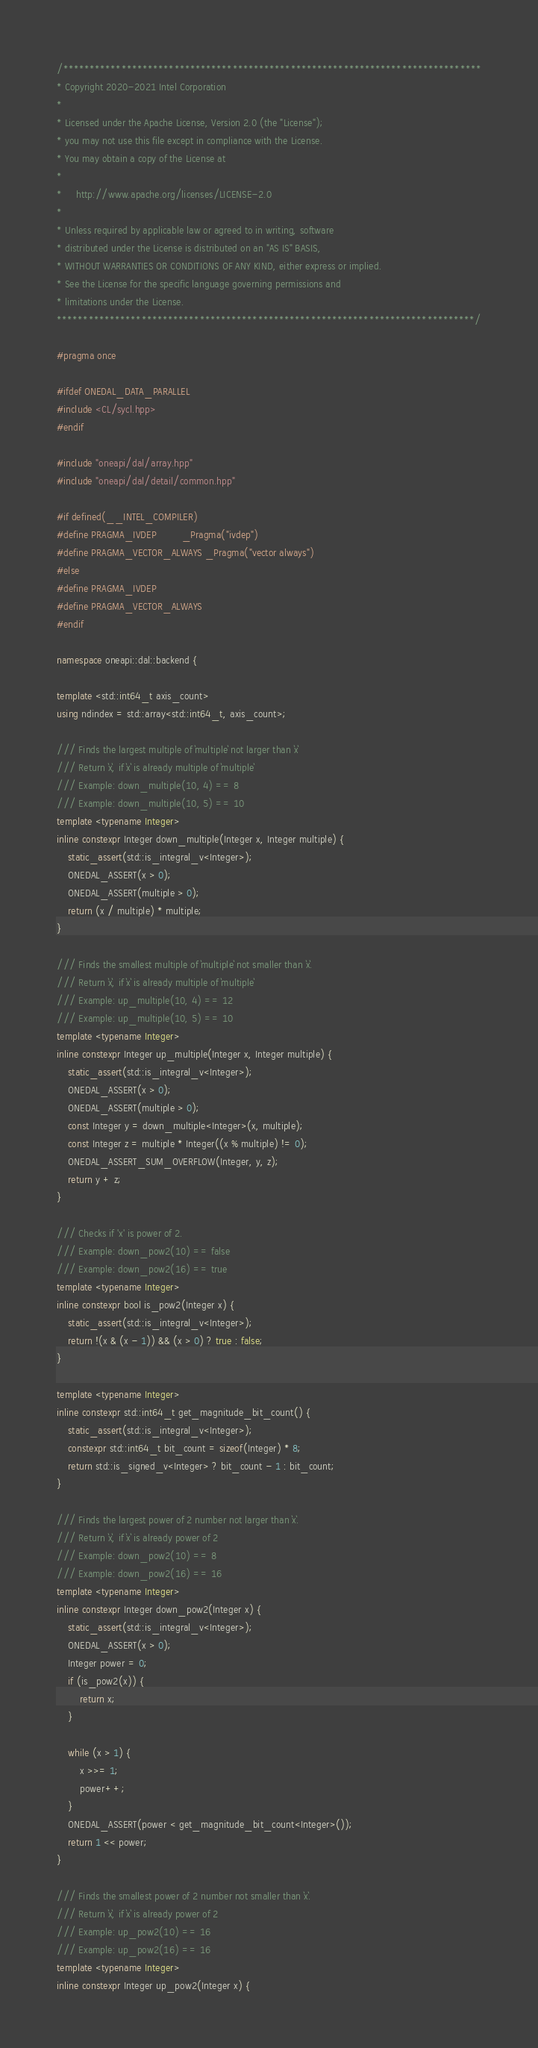<code> <loc_0><loc_0><loc_500><loc_500><_C++_>/*******************************************************************************
* Copyright 2020-2021 Intel Corporation
*
* Licensed under the Apache License, Version 2.0 (the "License");
* you may not use this file except in compliance with the License.
* You may obtain a copy of the License at
*
*     http://www.apache.org/licenses/LICENSE-2.0
*
* Unless required by applicable law or agreed to in writing, software
* distributed under the License is distributed on an "AS IS" BASIS,
* WITHOUT WARRANTIES OR CONDITIONS OF ANY KIND, either express or implied.
* See the License for the specific language governing permissions and
* limitations under the License.
*******************************************************************************/

#pragma once

#ifdef ONEDAL_DATA_PARALLEL
#include <CL/sycl.hpp>
#endif

#include "oneapi/dal/array.hpp"
#include "oneapi/dal/detail/common.hpp"

#if defined(__INTEL_COMPILER)
#define PRAGMA_IVDEP         _Pragma("ivdep")
#define PRAGMA_VECTOR_ALWAYS _Pragma("vector always")
#else
#define PRAGMA_IVDEP
#define PRAGMA_VECTOR_ALWAYS
#endif

namespace oneapi::dal::backend {

template <std::int64_t axis_count>
using ndindex = std::array<std::int64_t, axis_count>;

/// Finds the largest multiple of `multiple` not larger than `x`
/// Return `x`, if `x` is already multiple of `multiple`
/// Example: down_multiple(10, 4) == 8
/// Example: down_multiple(10, 5) == 10
template <typename Integer>
inline constexpr Integer down_multiple(Integer x, Integer multiple) {
    static_assert(std::is_integral_v<Integer>);
    ONEDAL_ASSERT(x > 0);
    ONEDAL_ASSERT(multiple > 0);
    return (x / multiple) * multiple;
}

/// Finds the smallest multiple of `multiple` not smaller than `x`.
/// Return `x`, if `x` is already multiple of `multiple`
/// Example: up_multiple(10, 4) == 12
/// Example: up_multiple(10, 5) == 10
template <typename Integer>
inline constexpr Integer up_multiple(Integer x, Integer multiple) {
    static_assert(std::is_integral_v<Integer>);
    ONEDAL_ASSERT(x > 0);
    ONEDAL_ASSERT(multiple > 0);
    const Integer y = down_multiple<Integer>(x, multiple);
    const Integer z = multiple * Integer((x % multiple) != 0);
    ONEDAL_ASSERT_SUM_OVERFLOW(Integer, y, z);
    return y + z;
}

/// Checks if 'x' is power of 2.
/// Example: down_pow2(10) == false
/// Example: down_pow2(16) == true
template <typename Integer>
inline constexpr bool is_pow2(Integer x) {
    static_assert(std::is_integral_v<Integer>);
    return !(x & (x - 1)) && (x > 0) ? true : false;
}

template <typename Integer>
inline constexpr std::int64_t get_magnitude_bit_count() {
    static_assert(std::is_integral_v<Integer>);
    constexpr std::int64_t bit_count = sizeof(Integer) * 8;
    return std::is_signed_v<Integer> ? bit_count - 1 : bit_count;
}

/// Finds the largest power of 2 number not larger than `x`.
/// Return `x`, if `x` is already power of 2
/// Example: down_pow2(10) == 8
/// Example: down_pow2(16) == 16
template <typename Integer>
inline constexpr Integer down_pow2(Integer x) {
    static_assert(std::is_integral_v<Integer>);
    ONEDAL_ASSERT(x > 0);
    Integer power = 0;
    if (is_pow2(x)) {
        return x;
    }

    while (x > 1) {
        x >>= 1;
        power++;
    }
    ONEDAL_ASSERT(power < get_magnitude_bit_count<Integer>());
    return 1 << power;
}

/// Finds the smallest power of 2 number not smaller than `x`.
/// Return `x`, if `x` is already power of 2
/// Example: up_pow2(10) == 16
/// Example: up_pow2(16) == 16
template <typename Integer>
inline constexpr Integer up_pow2(Integer x) {</code> 